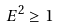Convert formula to latex. <formula><loc_0><loc_0><loc_500><loc_500>E ^ { 2 } \geq 1</formula> 